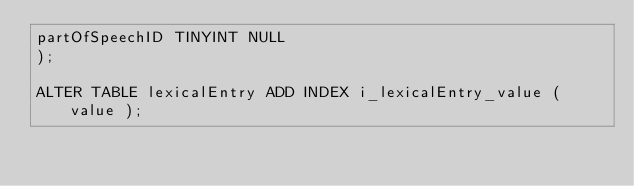Convert code to text. <code><loc_0><loc_0><loc_500><loc_500><_SQL_>partOfSpeechID TINYINT NULL
);

ALTER TABLE lexicalEntry ADD INDEX i_lexicalEntry_value ( value );</code> 